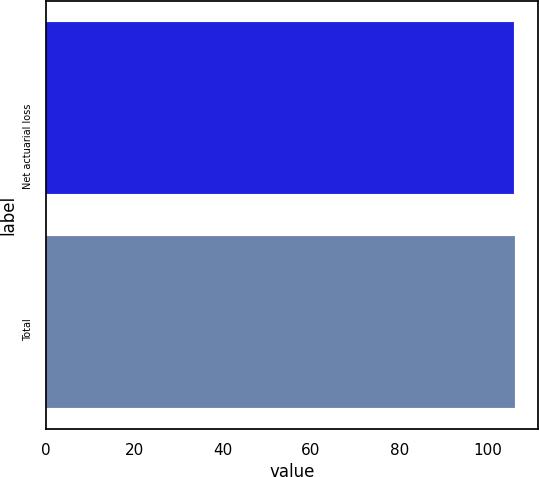Convert chart to OTSL. <chart><loc_0><loc_0><loc_500><loc_500><bar_chart><fcel>Net actuarial loss<fcel>Total<nl><fcel>106<fcel>106.1<nl></chart> 